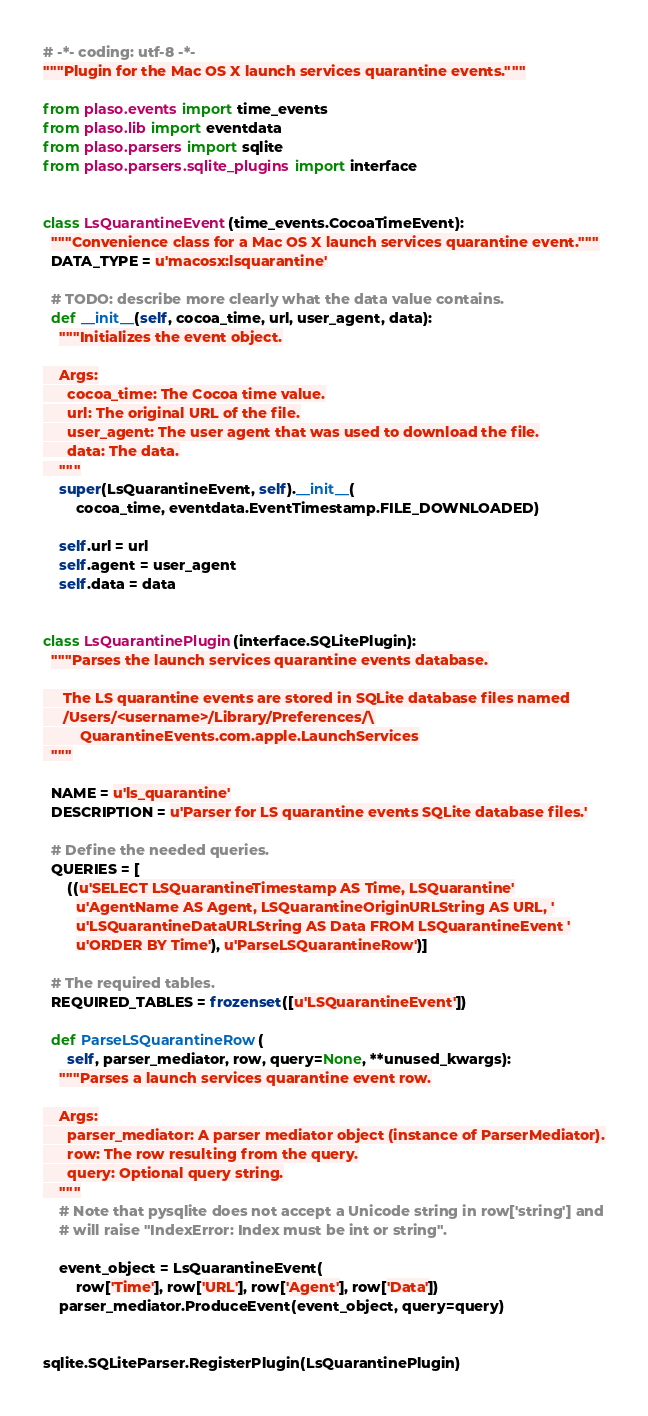Convert code to text. <code><loc_0><loc_0><loc_500><loc_500><_Python_># -*- coding: utf-8 -*-
"""Plugin for the Mac OS X launch services quarantine events."""

from plaso.events import time_events
from plaso.lib import eventdata
from plaso.parsers import sqlite
from plaso.parsers.sqlite_plugins import interface


class LsQuarantineEvent(time_events.CocoaTimeEvent):
  """Convenience class for a Mac OS X launch services quarantine event."""
  DATA_TYPE = u'macosx:lsquarantine'

  # TODO: describe more clearly what the data value contains.
  def __init__(self, cocoa_time, url, user_agent, data):
    """Initializes the event object.

    Args:
      cocoa_time: The Cocoa time value.
      url: The original URL of the file.
      user_agent: The user agent that was used to download the file.
      data: The data.
    """
    super(LsQuarantineEvent, self).__init__(
        cocoa_time, eventdata.EventTimestamp.FILE_DOWNLOADED)

    self.url = url
    self.agent = user_agent
    self.data = data


class LsQuarantinePlugin(interface.SQLitePlugin):
  """Parses the launch services quarantine events database.

     The LS quarantine events are stored in SQLite database files named
     /Users/<username>/Library/Preferences/\
         QuarantineEvents.com.apple.LaunchServices
  """

  NAME = u'ls_quarantine'
  DESCRIPTION = u'Parser for LS quarantine events SQLite database files.'

  # Define the needed queries.
  QUERIES = [
      ((u'SELECT LSQuarantineTimestamp AS Time, LSQuarantine'
        u'AgentName AS Agent, LSQuarantineOriginURLString AS URL, '
        u'LSQuarantineDataURLString AS Data FROM LSQuarantineEvent '
        u'ORDER BY Time'), u'ParseLSQuarantineRow')]

  # The required tables.
  REQUIRED_TABLES = frozenset([u'LSQuarantineEvent'])

  def ParseLSQuarantineRow(
      self, parser_mediator, row, query=None, **unused_kwargs):
    """Parses a launch services quarantine event row.

    Args:
      parser_mediator: A parser mediator object (instance of ParserMediator).
      row: The row resulting from the query.
      query: Optional query string.
    """
    # Note that pysqlite does not accept a Unicode string in row['string'] and
    # will raise "IndexError: Index must be int or string".

    event_object = LsQuarantineEvent(
        row['Time'], row['URL'], row['Agent'], row['Data'])
    parser_mediator.ProduceEvent(event_object, query=query)


sqlite.SQLiteParser.RegisterPlugin(LsQuarantinePlugin)
</code> 